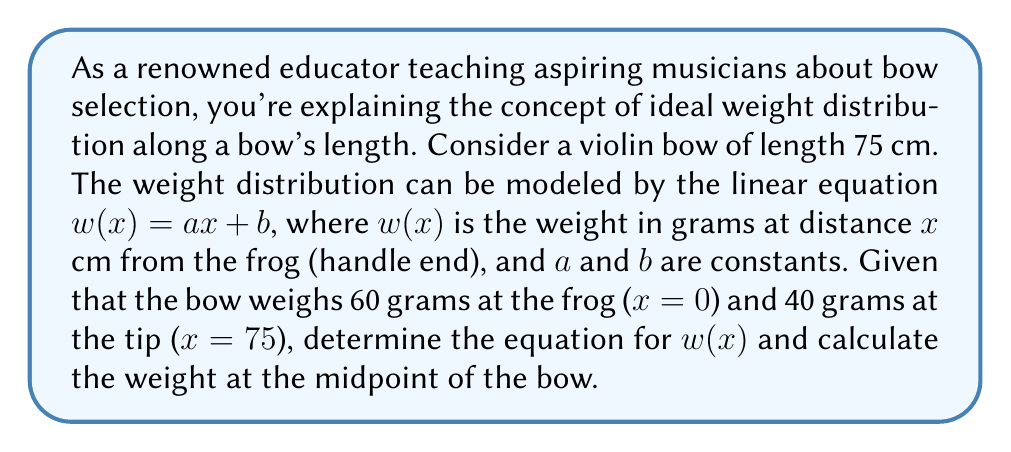Teach me how to tackle this problem. Let's approach this step-by-step:

1) We're given that the weight distribution follows the linear equation:
   $w(x) = ax + b$

2) We know two points on this line:
   At $x = 0$ (frog), $w(0) = 60$
   At $x = 75$ (tip), $w(75) = 40$

3) Let's use these points to find $a$ and $b$:

   For $x = 0$: $60 = a(0) + b$, so $b = 60$

   For $x = 75$: $40 = a(75) + 60$

4) Solve for $a$:
   $40 = 75a + 60$
   $-20 = 75a$
   $a = -\frac{20}{75} = -\frac{4}{15}$

5) Now we have our equation:
   $w(x) = -\frac{4}{15}x + 60$

6) To find the weight at the midpoint, we calculate $x$ at the midpoint:
   Midpoint = $\frac{75}{2} = 37.5$ cm

7) Substitute this into our equation:
   $w(37.5) = -\frac{4}{15}(37.5) + 60$
   $= -10 + 60 = 50$

Therefore, the weight at the midpoint is 50 grams.
Answer: The weight distribution equation is $w(x) = -\frac{4}{15}x + 60$, and the weight at the midpoint of the bow is 50 grams. 